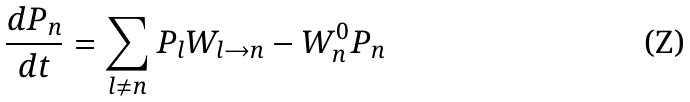<formula> <loc_0><loc_0><loc_500><loc_500>\frac { d P _ { n } } { d t } = \sum _ { l \neq n } P _ { l } W _ { l \to n } - W _ { n } ^ { 0 } P _ { n }</formula> 